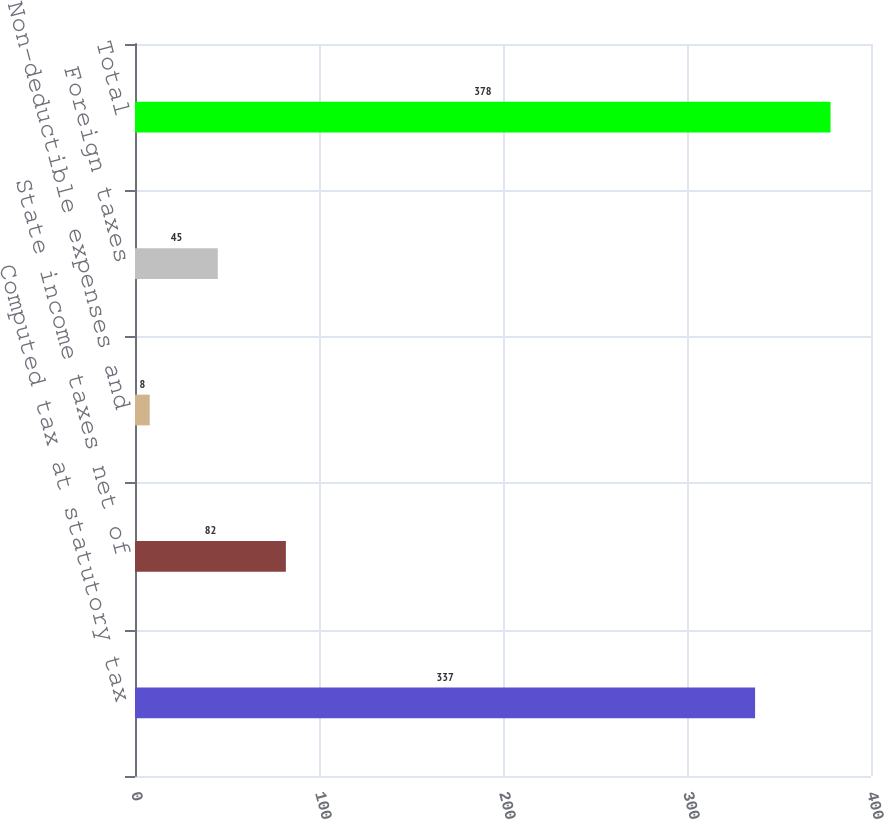<chart> <loc_0><loc_0><loc_500><loc_500><bar_chart><fcel>Computed tax at statutory tax<fcel>State income taxes net of<fcel>Non-deductible expenses and<fcel>Foreign taxes<fcel>Total<nl><fcel>337<fcel>82<fcel>8<fcel>45<fcel>378<nl></chart> 